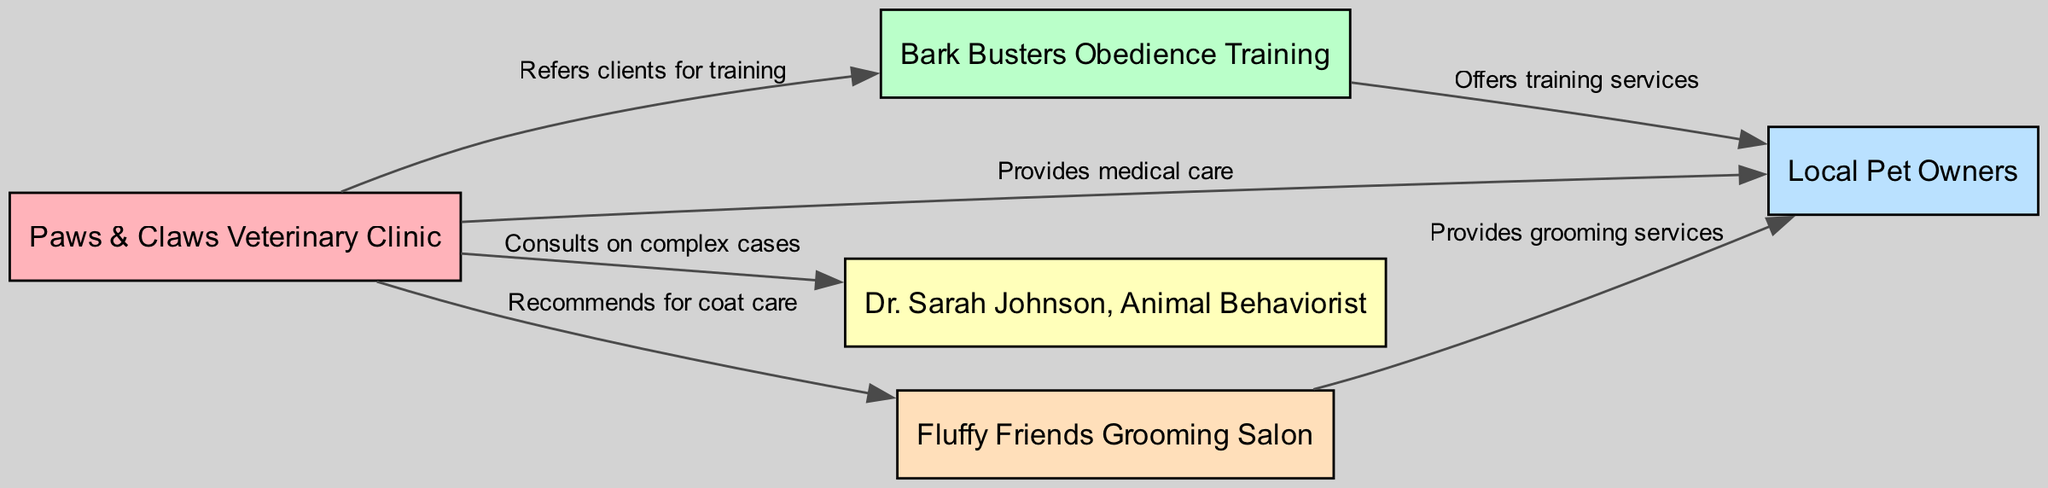What is the label of the node representing veterinarians? The node that represents veterinarians in the diagram is labeled "Paws & Claws Veterinary Clinic."
Answer: Paws & Claws Veterinary Clinic How many nodes are there in the diagram? By counting each unique entity represented, there are a total of five nodes: veterinarians, obedience trainers, pet owners, an animal behaviorist, and a groomer.
Answer: 5 What type of service does "Bark Busters Obedience Training" offer? The diagram indicates that "Bark Busters Obedience Training" offers training services to pet owners, as specified in the edge label.
Answer: Training services Which node connects both "Paws & Claws Veterinary Clinic" and "Dr. Sarah Johnson, Animal Behaviorist"? The connection comes from the "Paws & Claws Veterinary Clinic" node, which directs to "Dr. Sarah Johnson, Animal Behaviorist" showing they are linked through consultations.
Answer: Paws & Claws Veterinary Clinic What is the relationship between the "Paws & Claws Veterinary Clinic" and pet owners? The relationship described in the diagram indicates that the clinic provides medical care to pet owners, establishing a direct service connection.
Answer: Provides medical care What services does "Fluffy Friends Grooming Salon" provide? According to the diagram, "Fluffy Friends Grooming Salon" provides grooming services to pet owners as depicted in the edge label.
Answer: Grooming services How many edges connect "Paws & Claws Veterinary Clinic" to other nodes? After examining the edges, it can be seen that there are four edges connected to "Paws & Claws Veterinary Clinic," indicating multiple relationships with other specialists and pet owners.
Answer: 4 Which node is recommended by "Paws & Claws Veterinary Clinic" for coat care? The diagram clearly illustrates that "Paws & Claws Veterinary Clinic" recommends "Fluffy Friends Grooming Salon" for coat care, as stated in the respective edge.
Answer: Fluffy Friends Grooming Salon What is the primary role of "Dr. Sarah Johnson, Animal Behaviorist" in this network? Within the diagram's context, "Dr. Sarah Johnson, Animal Behaviorist" serves to consult on complex cases referred by veterinarians, indicating a specialized role.
Answer: Consults on complex cases 